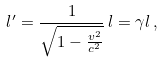Convert formula to latex. <formula><loc_0><loc_0><loc_500><loc_500>l ^ { \prime } = \frac { 1 } { \sqrt { 1 - \frac { v ^ { 2 } } { c ^ { 2 } } } } \, l = \gamma l \, ,</formula> 